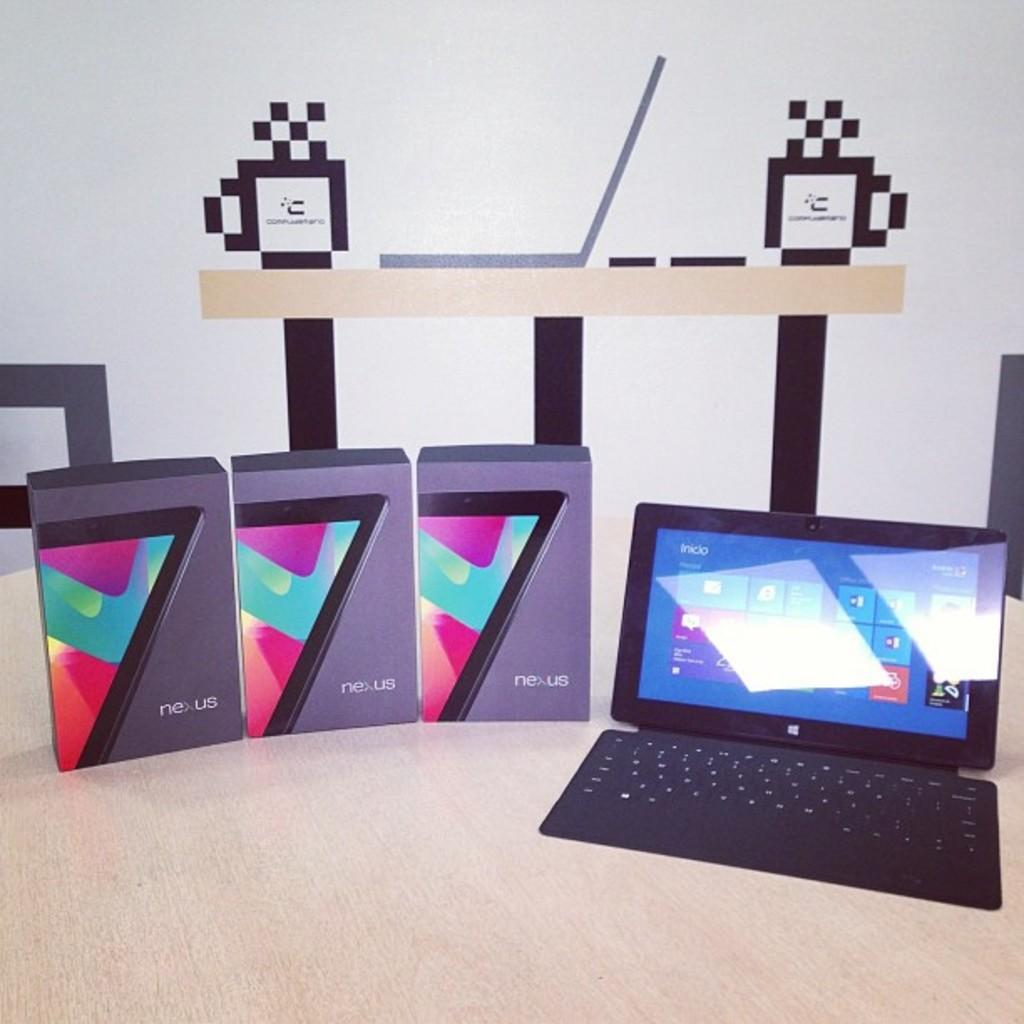What type of furniture is present in the image? There is a wooden table in the image. What electronic device is on the table? There is a laptop on the table. How many boxes are on the table? There are three boxes on the table. What can be seen behind the table in the image? There is a wall visible in the image. What is the appearance of the wall? There is a design on the wall. What type of cheese is being grated on the back of the laptop in the image? There is no cheese or grating activity present in the image; the laptop is simply placed on the table. 